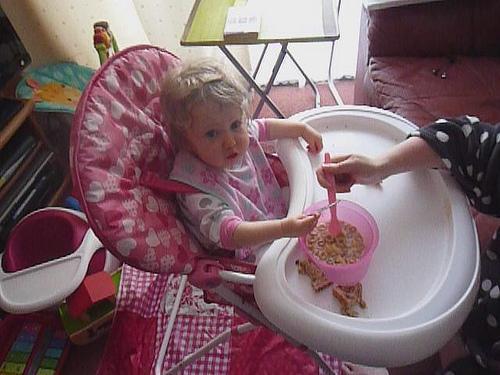How many highchairs are there in this picture?
Give a very brief answer. 1. 